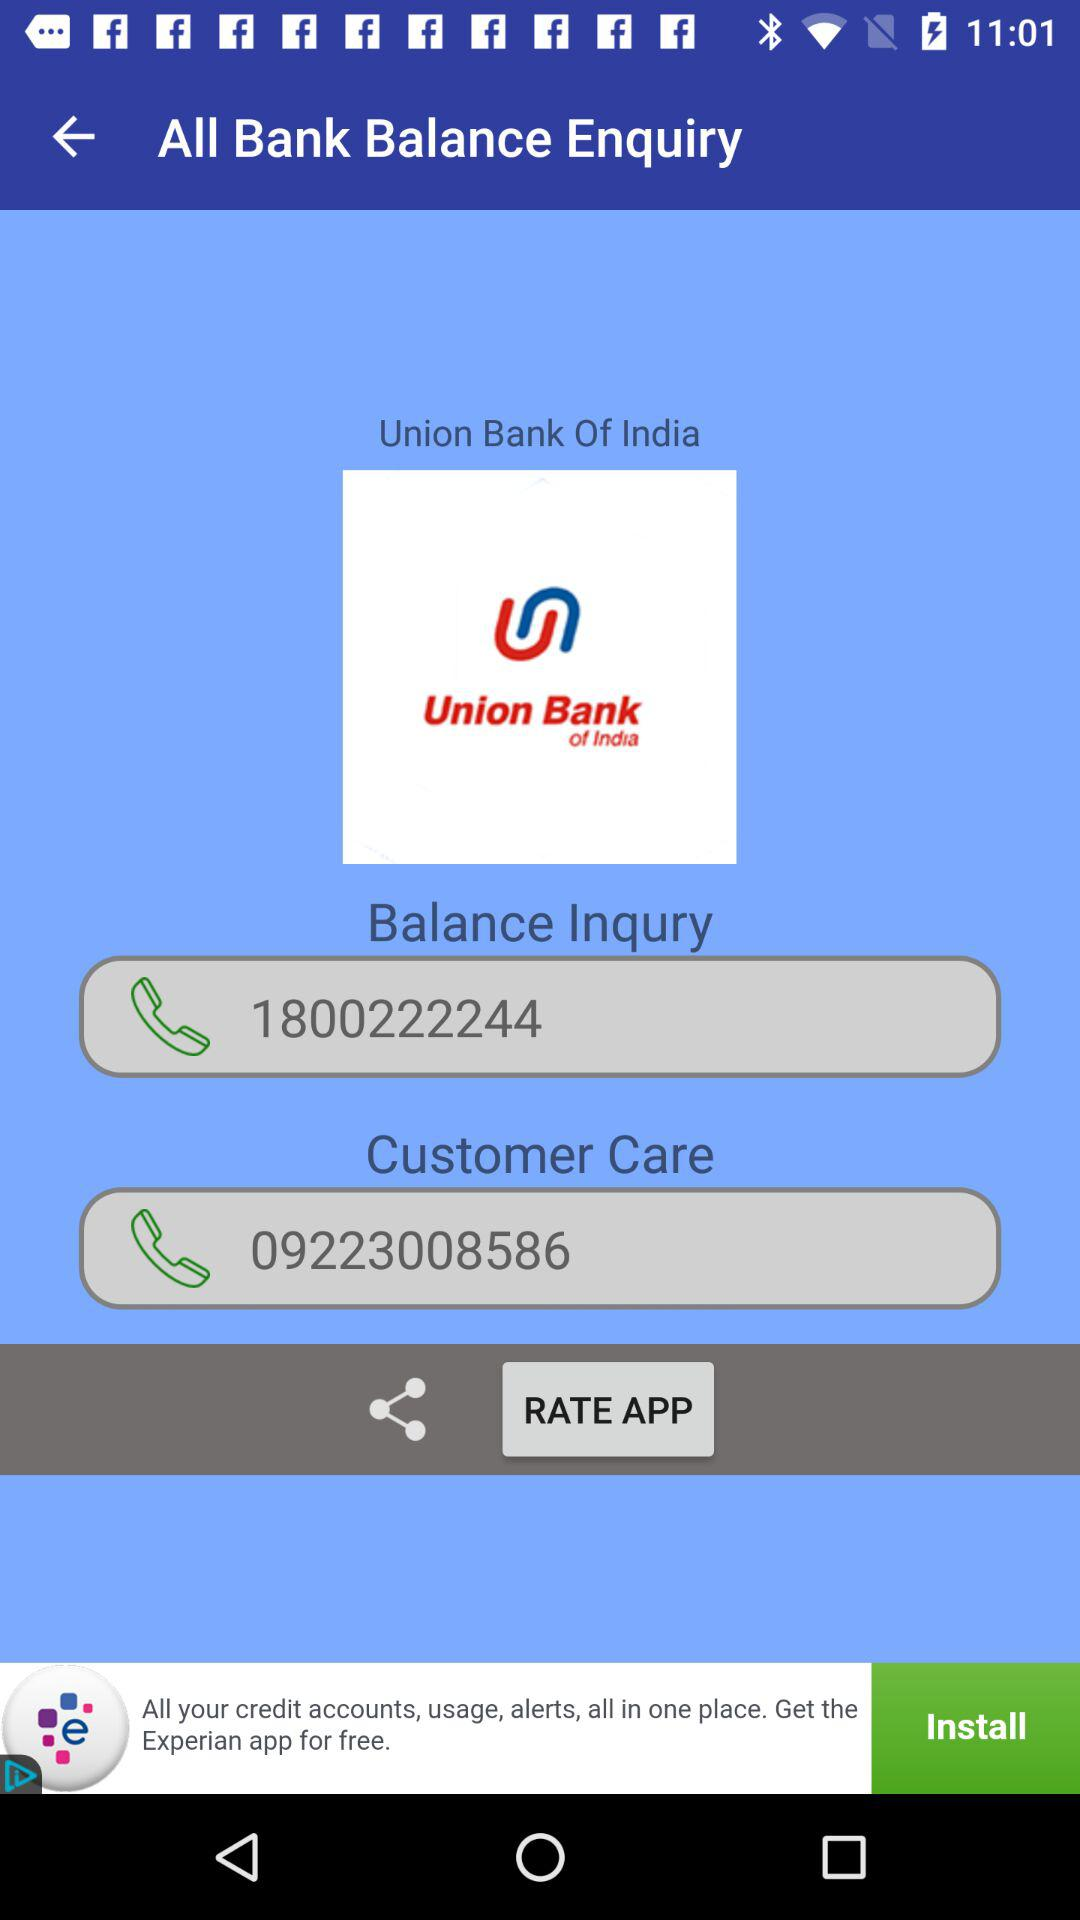Which bank's name is shown on the inquiry page? The bank name shown on the inquiry page is "Union Bank Of India". 